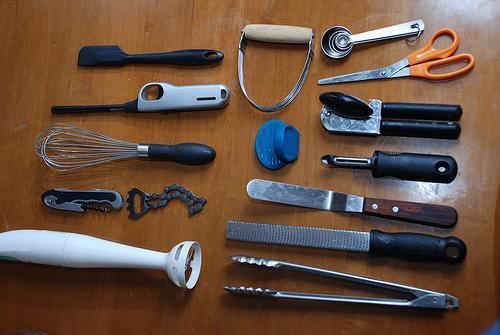How many whisks are shown?
Give a very brief answer. 1. How many measuring spoons are shown?
Give a very brief answer. 5. 